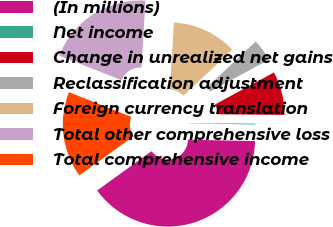Convert chart. <chart><loc_0><loc_0><loc_500><loc_500><pie_chart><fcel>(In millions)<fcel>Net income<fcel>Change in unrealized net gains<fcel>Reclassification adjustment<fcel>Foreign currency translation<fcel>Total other comprehensive loss<fcel>Total comprehensive income<nl><fcel>39.72%<fcel>0.16%<fcel>8.07%<fcel>4.11%<fcel>12.03%<fcel>19.94%<fcel>15.98%<nl></chart> 